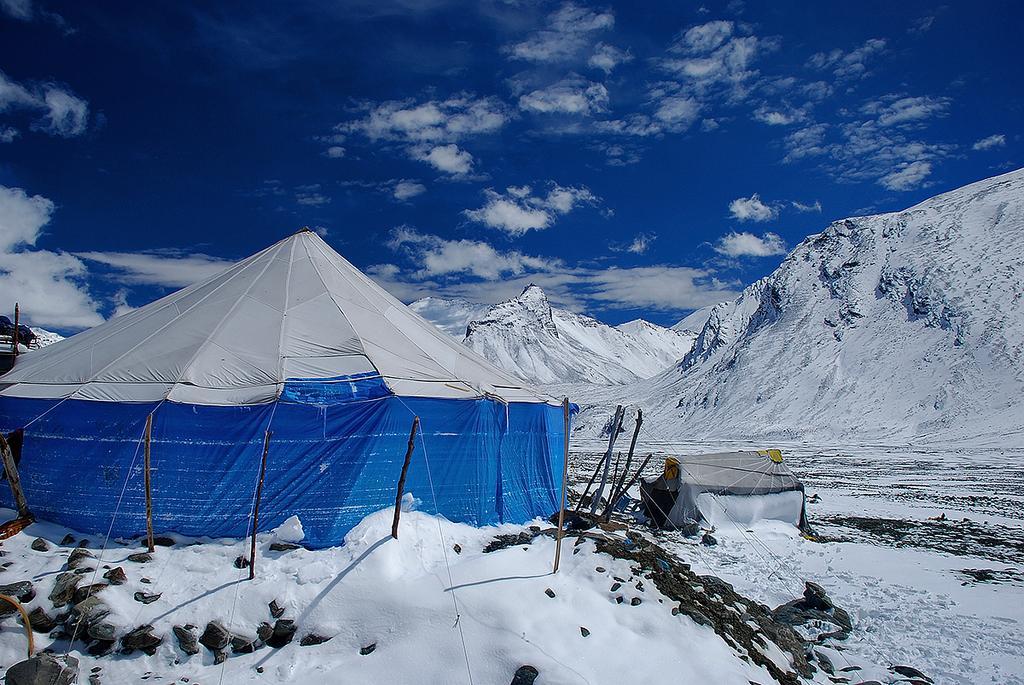Please provide a concise description of this image. In this image there is a tent in the middle of the snow. In the background there are snow mountains. At the top there is sky. Beside the text there is a small hut. At the bottom there is snow. 